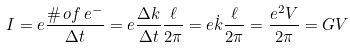<formula> <loc_0><loc_0><loc_500><loc_500>I = e \frac { \# \, o f \, e ^ { - } } { \Delta t } = e \frac { \Delta k } { \Delta t } \frac { \ell } { 2 \pi } = e \dot { k } \frac { \ell } { 2 \pi } = \frac { e ^ { 2 } V } { 2 \pi } = G V</formula> 